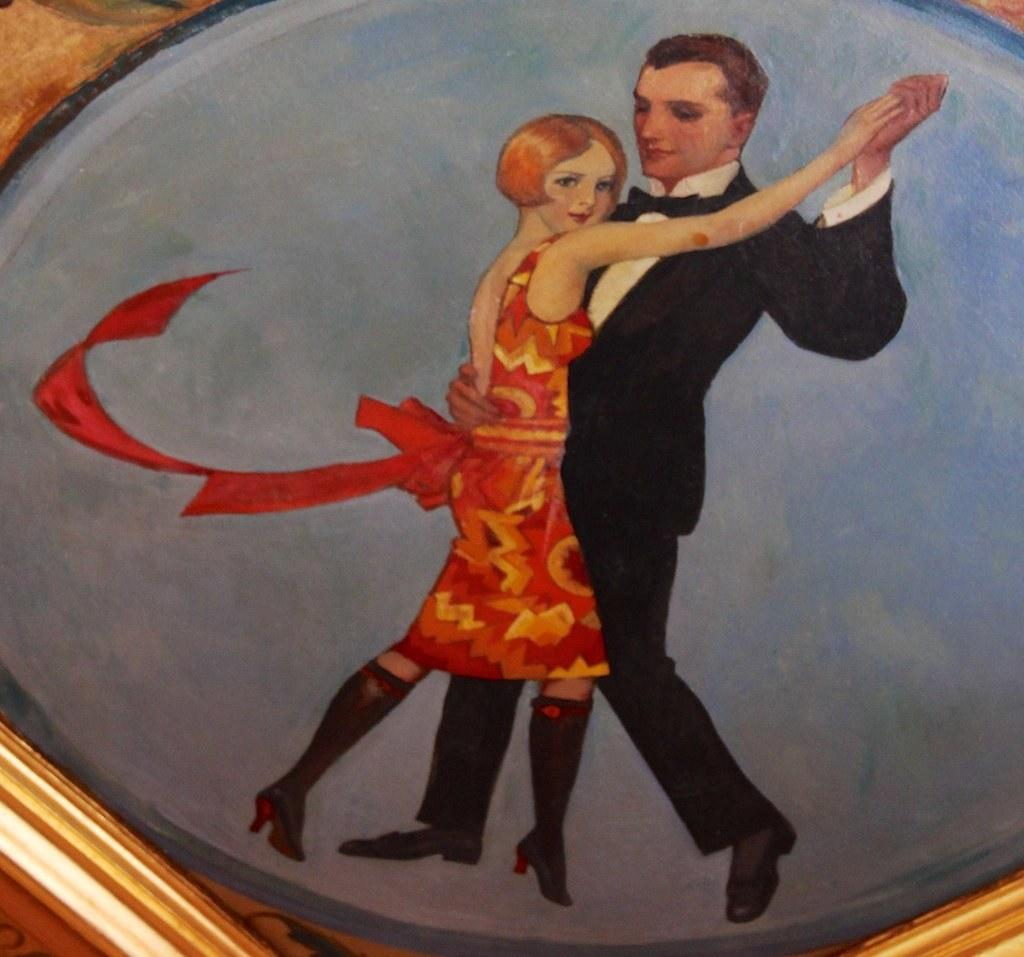What object is present in the image that typically holds a photograph or artwork? There is a photo frame in the image. What is displayed within the photo frame? The photo frame contains a painted picture. What scene is depicted in the painted picture? The painted picture depicts a man and a woman dancing together. What type of flame can be seen burning in the background of the painted picture? There is no flame present in the image, as the painted picture depicts a man and a woman dancing together without any background elements. 